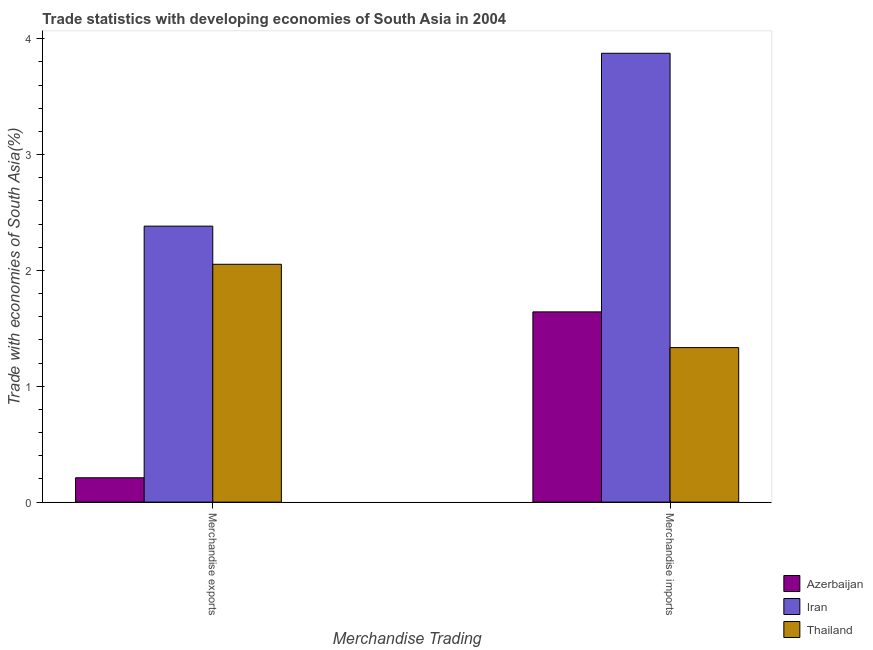Are the number of bars per tick equal to the number of legend labels?
Provide a succinct answer. Yes. Are the number of bars on each tick of the X-axis equal?
Give a very brief answer. Yes. How many bars are there on the 1st tick from the left?
Your response must be concise. 3. How many bars are there on the 1st tick from the right?
Your answer should be compact. 3. What is the merchandise exports in Thailand?
Offer a terse response. 2.05. Across all countries, what is the maximum merchandise exports?
Offer a terse response. 2.38. Across all countries, what is the minimum merchandise exports?
Offer a terse response. 0.21. In which country was the merchandise exports maximum?
Your response must be concise. Iran. In which country was the merchandise exports minimum?
Your answer should be very brief. Azerbaijan. What is the total merchandise exports in the graph?
Provide a succinct answer. 4.65. What is the difference between the merchandise imports in Azerbaijan and that in Iran?
Offer a very short reply. -2.23. What is the difference between the merchandise imports in Iran and the merchandise exports in Azerbaijan?
Your answer should be compact. 3.66. What is the average merchandise imports per country?
Your answer should be very brief. 2.28. What is the difference between the merchandise exports and merchandise imports in Azerbaijan?
Provide a short and direct response. -1.43. What is the ratio of the merchandise imports in Thailand to that in Iran?
Your answer should be very brief. 0.34. What does the 3rd bar from the left in Merchandise exports represents?
Your answer should be very brief. Thailand. What does the 2nd bar from the right in Merchandise imports represents?
Keep it short and to the point. Iran. How many bars are there?
Provide a succinct answer. 6. What is the difference between two consecutive major ticks on the Y-axis?
Make the answer very short. 1. Does the graph contain grids?
Give a very brief answer. No. How many legend labels are there?
Provide a short and direct response. 3. How are the legend labels stacked?
Your answer should be compact. Vertical. What is the title of the graph?
Keep it short and to the point. Trade statistics with developing economies of South Asia in 2004. Does "Hungary" appear as one of the legend labels in the graph?
Provide a succinct answer. No. What is the label or title of the X-axis?
Your answer should be compact. Merchandise Trading. What is the label or title of the Y-axis?
Your response must be concise. Trade with economies of South Asia(%). What is the Trade with economies of South Asia(%) in Azerbaijan in Merchandise exports?
Make the answer very short. 0.21. What is the Trade with economies of South Asia(%) in Iran in Merchandise exports?
Offer a very short reply. 2.38. What is the Trade with economies of South Asia(%) in Thailand in Merchandise exports?
Your answer should be compact. 2.05. What is the Trade with economies of South Asia(%) in Azerbaijan in Merchandise imports?
Give a very brief answer. 1.64. What is the Trade with economies of South Asia(%) of Iran in Merchandise imports?
Your answer should be very brief. 3.87. What is the Trade with economies of South Asia(%) in Thailand in Merchandise imports?
Keep it short and to the point. 1.33. Across all Merchandise Trading, what is the maximum Trade with economies of South Asia(%) in Azerbaijan?
Keep it short and to the point. 1.64. Across all Merchandise Trading, what is the maximum Trade with economies of South Asia(%) of Iran?
Ensure brevity in your answer.  3.87. Across all Merchandise Trading, what is the maximum Trade with economies of South Asia(%) in Thailand?
Your response must be concise. 2.05. Across all Merchandise Trading, what is the minimum Trade with economies of South Asia(%) of Azerbaijan?
Your response must be concise. 0.21. Across all Merchandise Trading, what is the minimum Trade with economies of South Asia(%) of Iran?
Keep it short and to the point. 2.38. Across all Merchandise Trading, what is the minimum Trade with economies of South Asia(%) of Thailand?
Offer a terse response. 1.33. What is the total Trade with economies of South Asia(%) in Azerbaijan in the graph?
Provide a short and direct response. 1.85. What is the total Trade with economies of South Asia(%) in Iran in the graph?
Offer a very short reply. 6.26. What is the total Trade with economies of South Asia(%) in Thailand in the graph?
Ensure brevity in your answer.  3.39. What is the difference between the Trade with economies of South Asia(%) in Azerbaijan in Merchandise exports and that in Merchandise imports?
Your answer should be very brief. -1.43. What is the difference between the Trade with economies of South Asia(%) in Iran in Merchandise exports and that in Merchandise imports?
Make the answer very short. -1.49. What is the difference between the Trade with economies of South Asia(%) in Thailand in Merchandise exports and that in Merchandise imports?
Make the answer very short. 0.72. What is the difference between the Trade with economies of South Asia(%) in Azerbaijan in Merchandise exports and the Trade with economies of South Asia(%) in Iran in Merchandise imports?
Give a very brief answer. -3.66. What is the difference between the Trade with economies of South Asia(%) of Azerbaijan in Merchandise exports and the Trade with economies of South Asia(%) of Thailand in Merchandise imports?
Your answer should be very brief. -1.12. What is the difference between the Trade with economies of South Asia(%) of Iran in Merchandise exports and the Trade with economies of South Asia(%) of Thailand in Merchandise imports?
Your answer should be very brief. 1.05. What is the average Trade with economies of South Asia(%) of Azerbaijan per Merchandise Trading?
Ensure brevity in your answer.  0.93. What is the average Trade with economies of South Asia(%) in Iran per Merchandise Trading?
Offer a very short reply. 3.13. What is the average Trade with economies of South Asia(%) of Thailand per Merchandise Trading?
Offer a terse response. 1.69. What is the difference between the Trade with economies of South Asia(%) of Azerbaijan and Trade with economies of South Asia(%) of Iran in Merchandise exports?
Make the answer very short. -2.17. What is the difference between the Trade with economies of South Asia(%) in Azerbaijan and Trade with economies of South Asia(%) in Thailand in Merchandise exports?
Keep it short and to the point. -1.84. What is the difference between the Trade with economies of South Asia(%) of Iran and Trade with economies of South Asia(%) of Thailand in Merchandise exports?
Give a very brief answer. 0.33. What is the difference between the Trade with economies of South Asia(%) of Azerbaijan and Trade with economies of South Asia(%) of Iran in Merchandise imports?
Provide a short and direct response. -2.23. What is the difference between the Trade with economies of South Asia(%) of Azerbaijan and Trade with economies of South Asia(%) of Thailand in Merchandise imports?
Offer a very short reply. 0.31. What is the difference between the Trade with economies of South Asia(%) of Iran and Trade with economies of South Asia(%) of Thailand in Merchandise imports?
Make the answer very short. 2.54. What is the ratio of the Trade with economies of South Asia(%) in Azerbaijan in Merchandise exports to that in Merchandise imports?
Provide a short and direct response. 0.13. What is the ratio of the Trade with economies of South Asia(%) in Iran in Merchandise exports to that in Merchandise imports?
Your response must be concise. 0.61. What is the ratio of the Trade with economies of South Asia(%) in Thailand in Merchandise exports to that in Merchandise imports?
Provide a short and direct response. 1.54. What is the difference between the highest and the second highest Trade with economies of South Asia(%) in Azerbaijan?
Provide a succinct answer. 1.43. What is the difference between the highest and the second highest Trade with economies of South Asia(%) in Iran?
Offer a terse response. 1.49. What is the difference between the highest and the second highest Trade with economies of South Asia(%) in Thailand?
Offer a very short reply. 0.72. What is the difference between the highest and the lowest Trade with economies of South Asia(%) of Azerbaijan?
Ensure brevity in your answer.  1.43. What is the difference between the highest and the lowest Trade with economies of South Asia(%) of Iran?
Your response must be concise. 1.49. What is the difference between the highest and the lowest Trade with economies of South Asia(%) of Thailand?
Your answer should be compact. 0.72. 